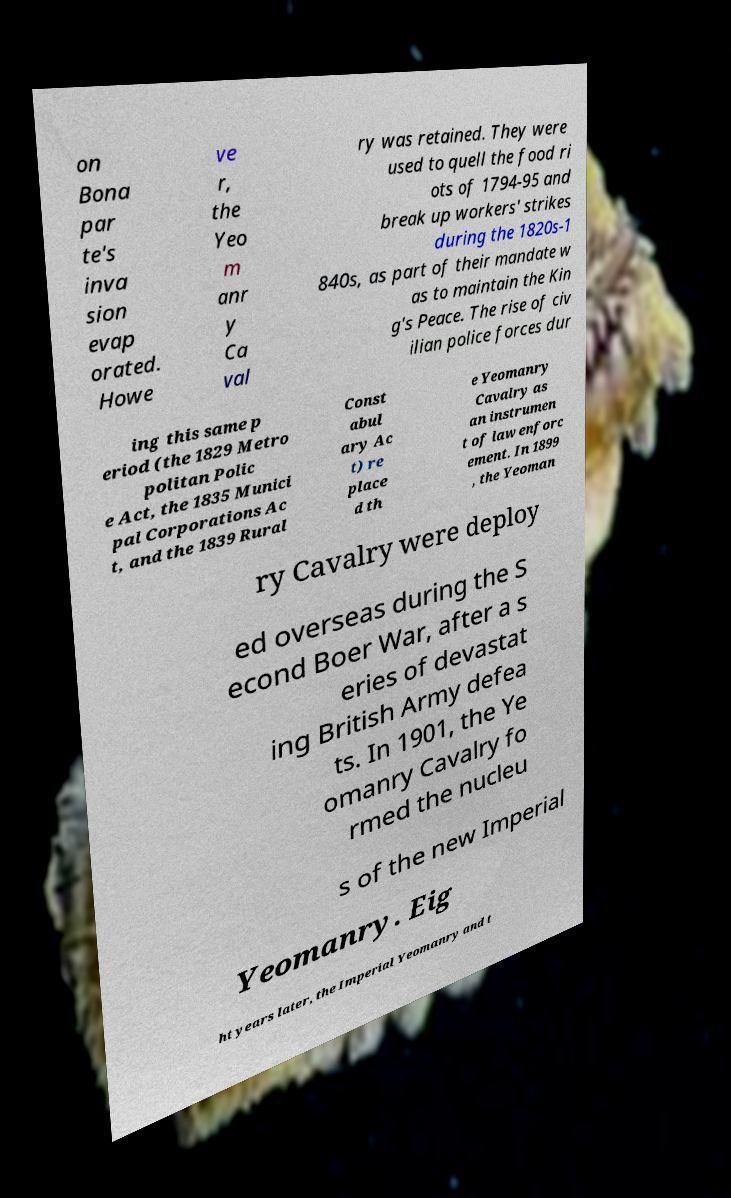For documentation purposes, I need the text within this image transcribed. Could you provide that? on Bona par te's inva sion evap orated. Howe ve r, the Yeo m anr y Ca val ry was retained. They were used to quell the food ri ots of 1794-95 and break up workers' strikes during the 1820s-1 840s, as part of their mandate w as to maintain the Kin g's Peace. The rise of civ ilian police forces dur ing this same p eriod (the 1829 Metro politan Polic e Act, the 1835 Munici pal Corporations Ac t, and the 1839 Rural Const abul ary Ac t) re place d th e Yeomanry Cavalry as an instrumen t of law enforc ement. In 1899 , the Yeoman ry Cavalry were deploy ed overseas during the S econd Boer War, after a s eries of devastat ing British Army defea ts. In 1901, the Ye omanry Cavalry fo rmed the nucleu s of the new Imperial Yeomanry. Eig ht years later, the Imperial Yeomanry and t 